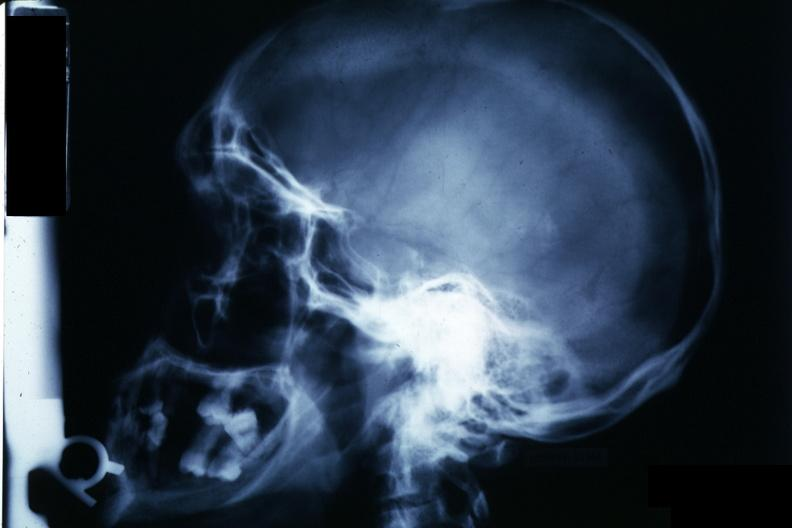s hemochromatosis present?
Answer the question using a single word or phrase. No 